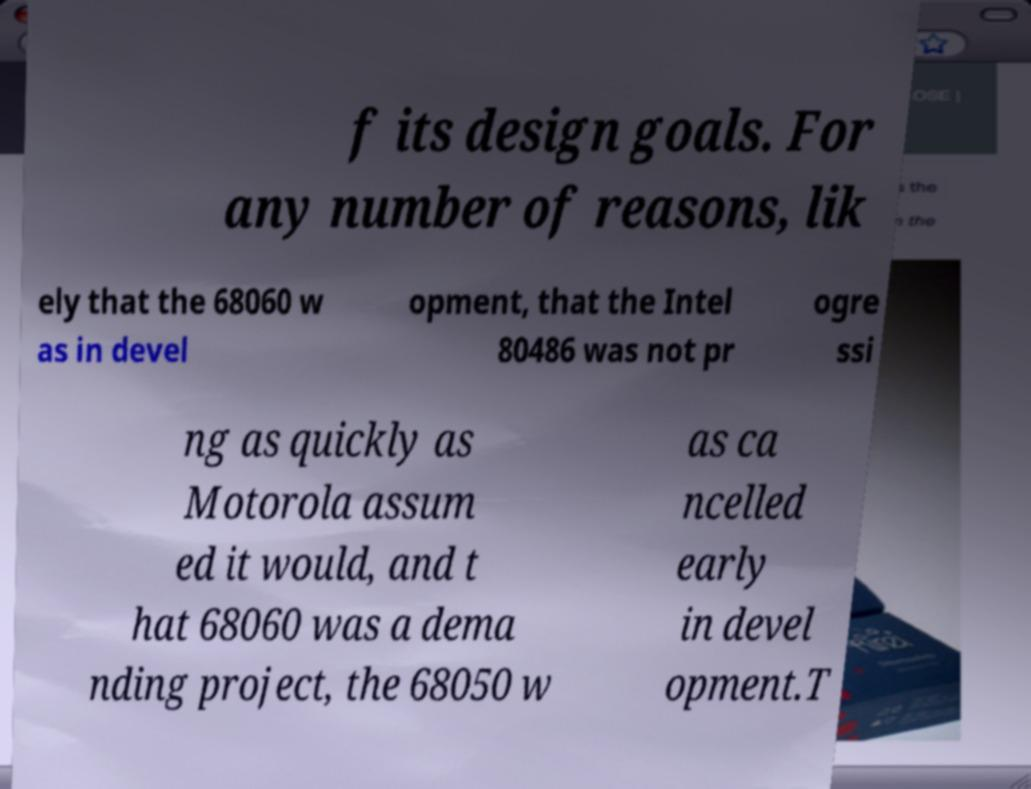For documentation purposes, I need the text within this image transcribed. Could you provide that? f its design goals. For any number of reasons, lik ely that the 68060 w as in devel opment, that the Intel 80486 was not pr ogre ssi ng as quickly as Motorola assum ed it would, and t hat 68060 was a dema nding project, the 68050 w as ca ncelled early in devel opment.T 